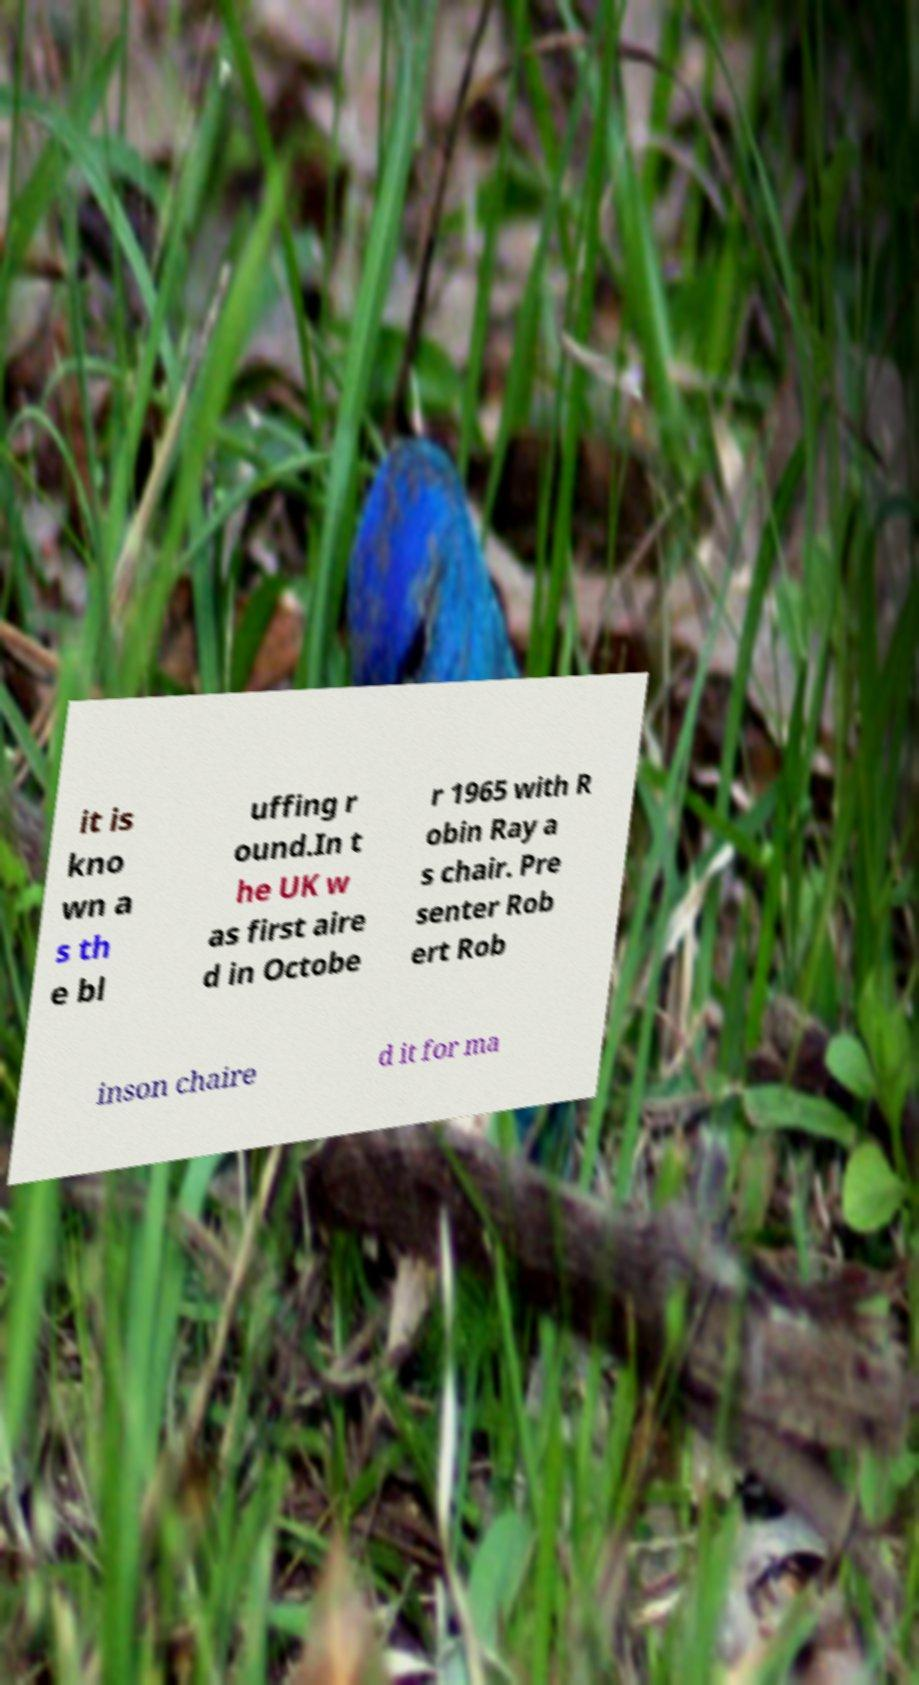Can you accurately transcribe the text from the provided image for me? it is kno wn a s th e bl uffing r ound.In t he UK w as first aire d in Octobe r 1965 with R obin Ray a s chair. Pre senter Rob ert Rob inson chaire d it for ma 